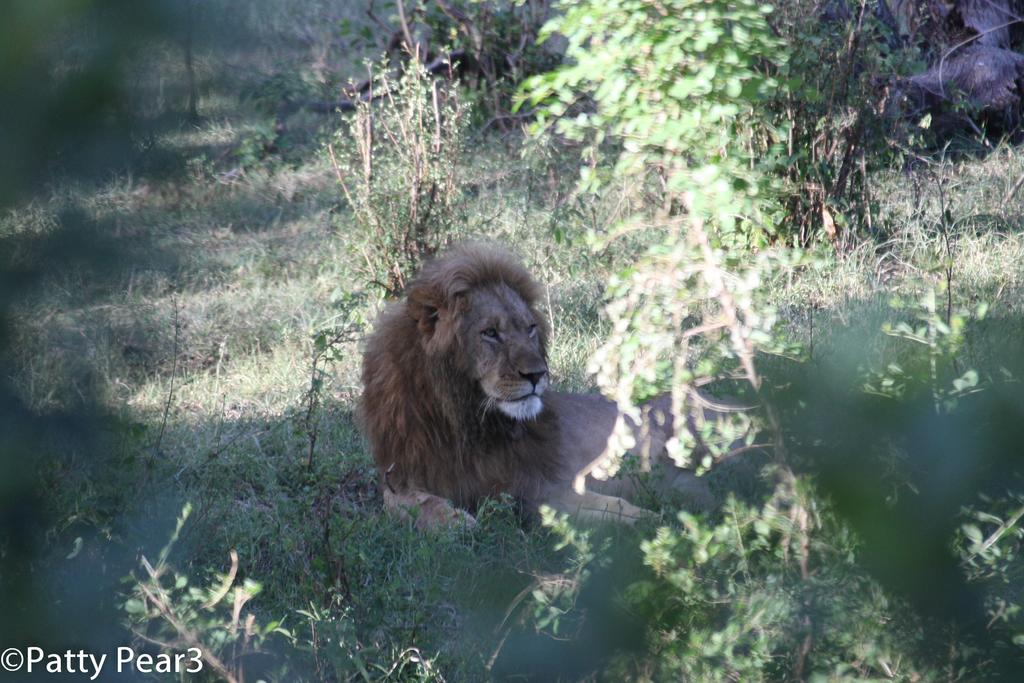Where was the image taken? The image was clicked outside. What type of vegetation can be seen in the image? There are plants and grass in the image. What is the main subject in the middle of the image? There is a lion in the middle of the image. What musical instrument is the lion playing in the image? There is no musical instrument present in the image, and the lion is not playing any instrument. 